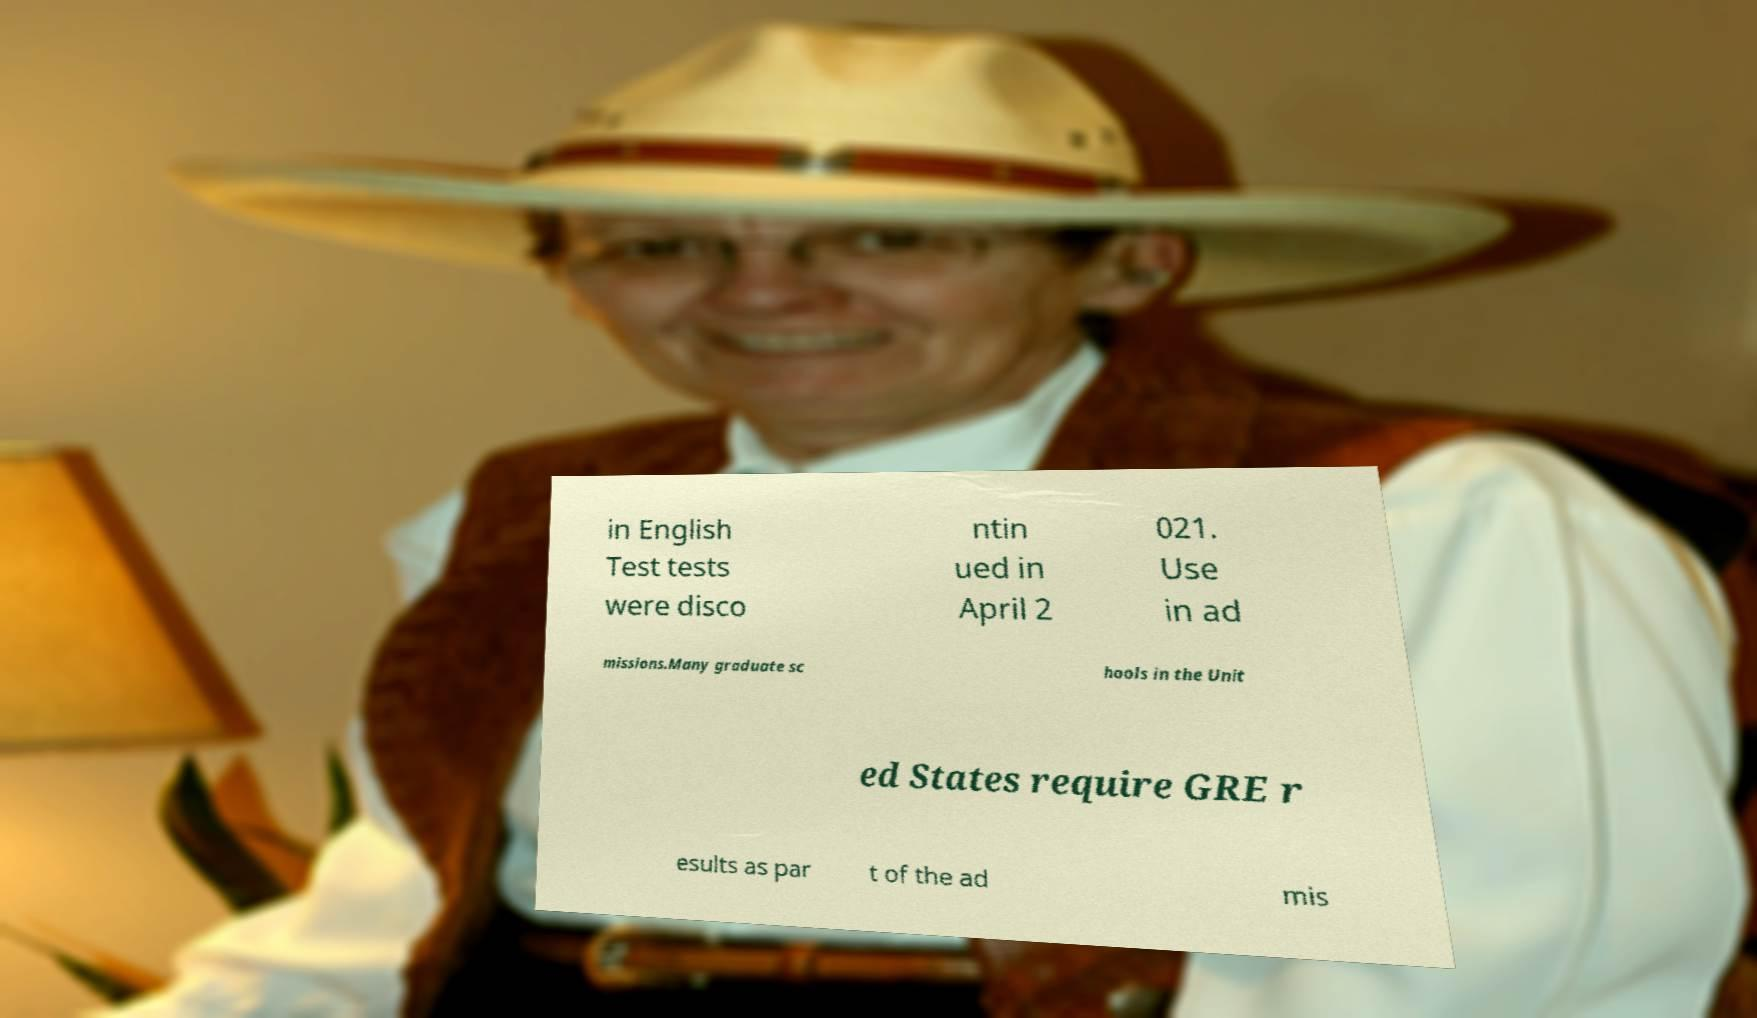Please identify and transcribe the text found in this image. in English Test tests were disco ntin ued in April 2 021. Use in ad missions.Many graduate sc hools in the Unit ed States require GRE r esults as par t of the ad mis 